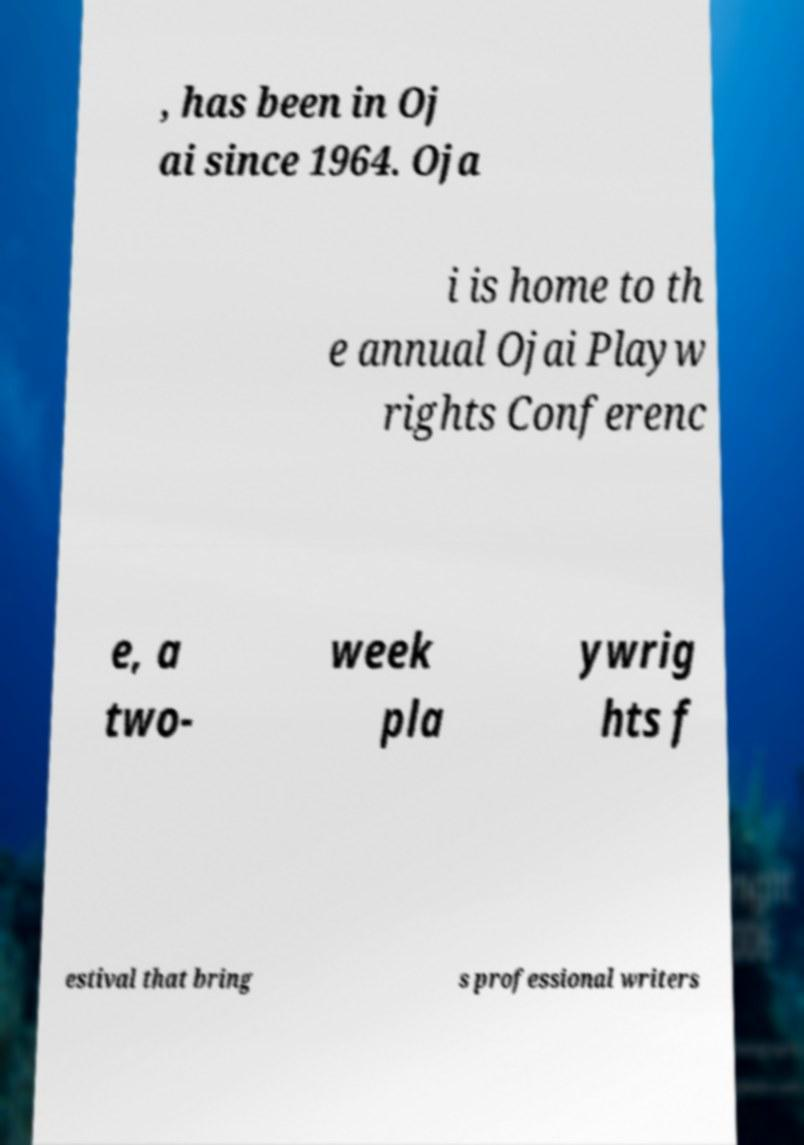What messages or text are displayed in this image? I need them in a readable, typed format. , has been in Oj ai since 1964. Oja i is home to th e annual Ojai Playw rights Conferenc e, a two- week pla ywrig hts f estival that bring s professional writers 